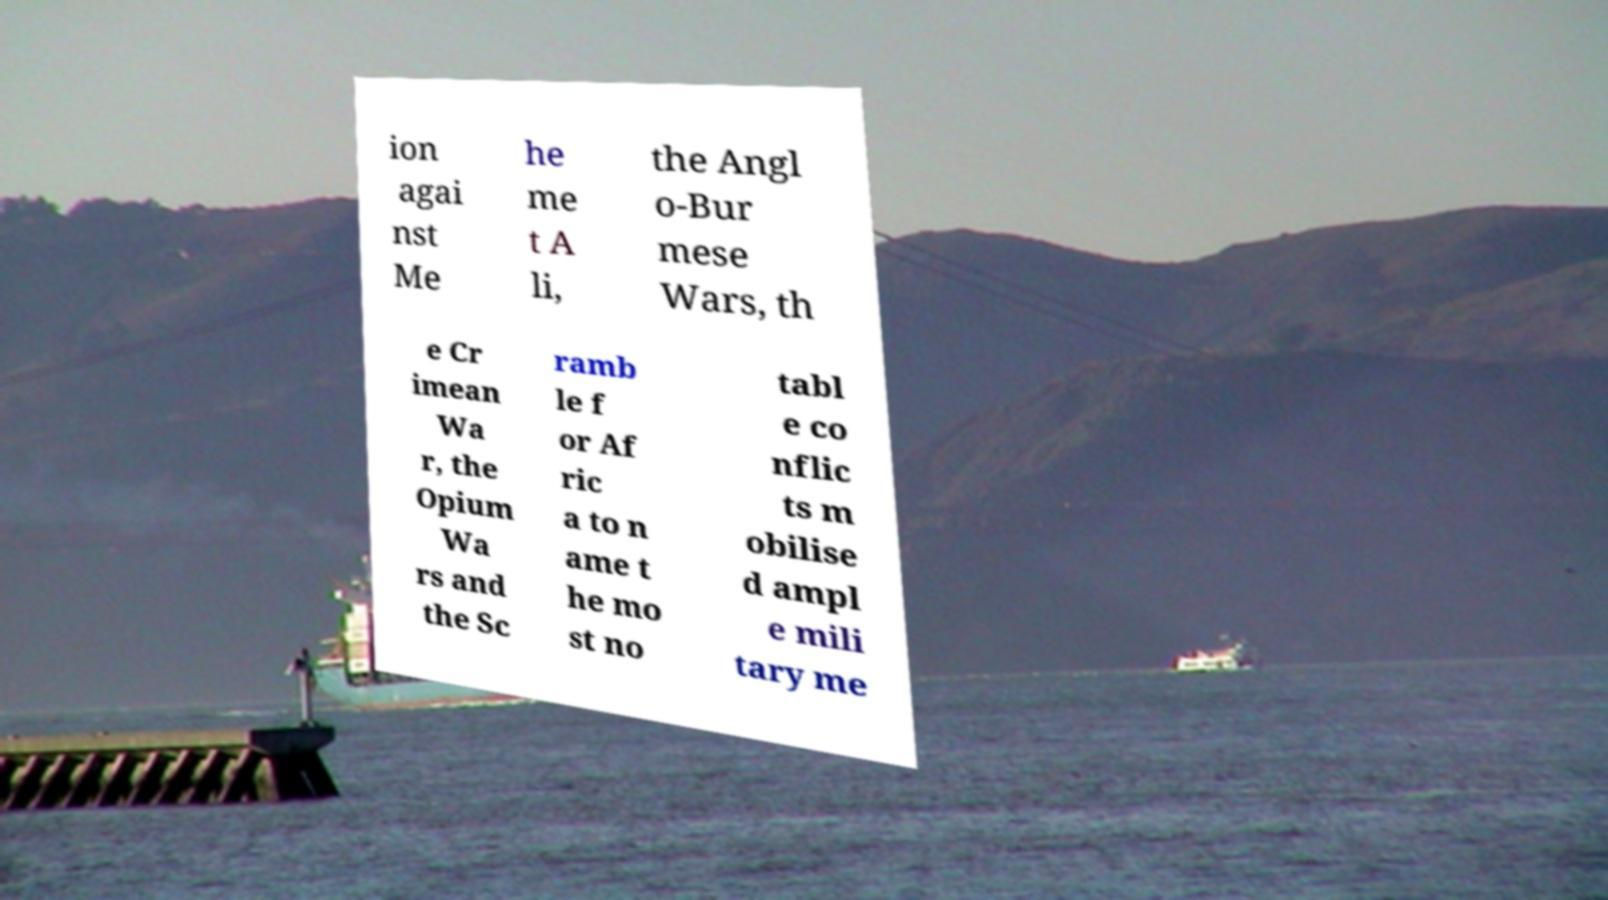Could you extract and type out the text from this image? ion agai nst Me he me t A li, the Angl o-Bur mese Wars, th e Cr imean Wa r, the Opium Wa rs and the Sc ramb le f or Af ric a to n ame t he mo st no tabl e co nflic ts m obilise d ampl e mili tary me 